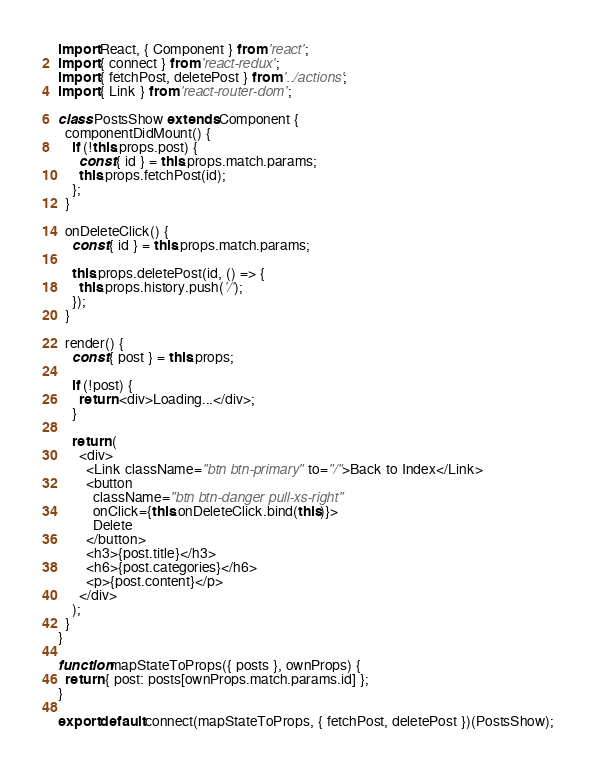<code> <loc_0><loc_0><loc_500><loc_500><_JavaScript_>import React, { Component } from 'react';
import { connect } from 'react-redux';
import { fetchPost, deletePost } from '../actions';
import { Link } from 'react-router-dom';

class PostsShow extends Component {
  componentDidMount() {
    if (!this.props.post) {
      const { id } = this.props.match.params;
      this.props.fetchPost(id);
    };
  }

  onDeleteClick() {
    const { id } = this.props.match.params;

    this.props.deletePost(id, () => {
      this.props.history.push('/');
    });
  }
  
  render() {
    const { post } = this.props;

    if (!post) {
      return <div>Loading...</div>;
    }

    return (
      <div>
        <Link className="btn btn-primary" to="/">Back to Index</Link>
        <button
          className="btn btn-danger pull-xs-right"
          onClick={this.onDeleteClick.bind(this)}>
          Delete
        </button>
        <h3>{post.title}</h3>
        <h6>{post.categories}</h6>
        <p>{post.content}</p>
      </div>
    );
  }
}

function mapStateToProps({ posts }, ownProps) {
  return { post: posts[ownProps.match.params.id] };
}

export default connect(mapStateToProps, { fetchPost, deletePost })(PostsShow);</code> 